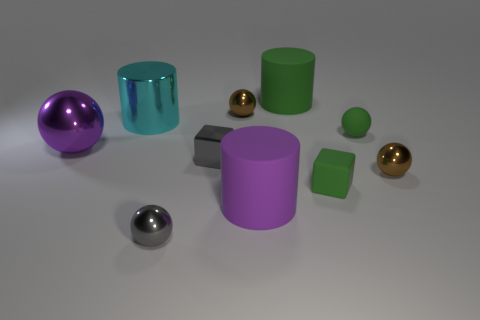How many other things are there of the same size as the purple matte cylinder?
Provide a short and direct response. 3. What number of blue matte spheres are there?
Your answer should be very brief. 0. Is the size of the shiny block the same as the matte ball?
Make the answer very short. Yes. What number of other objects are the same shape as the big cyan object?
Provide a succinct answer. 2. The green block to the right of the large cylinder that is in front of the gray block is made of what material?
Provide a succinct answer. Rubber. Are there any large green things behind the large purple cylinder?
Give a very brief answer. Yes. Does the purple metallic object have the same size as the cyan object that is behind the green sphere?
Provide a succinct answer. Yes. What size is the purple matte thing that is the same shape as the cyan metallic thing?
Ensure brevity in your answer.  Large. There is a metal cylinder behind the tiny gray metal sphere; is its size the same as the brown shiny sphere to the left of the green block?
Ensure brevity in your answer.  No. How many large things are blue matte cylinders or green rubber spheres?
Give a very brief answer. 0. 